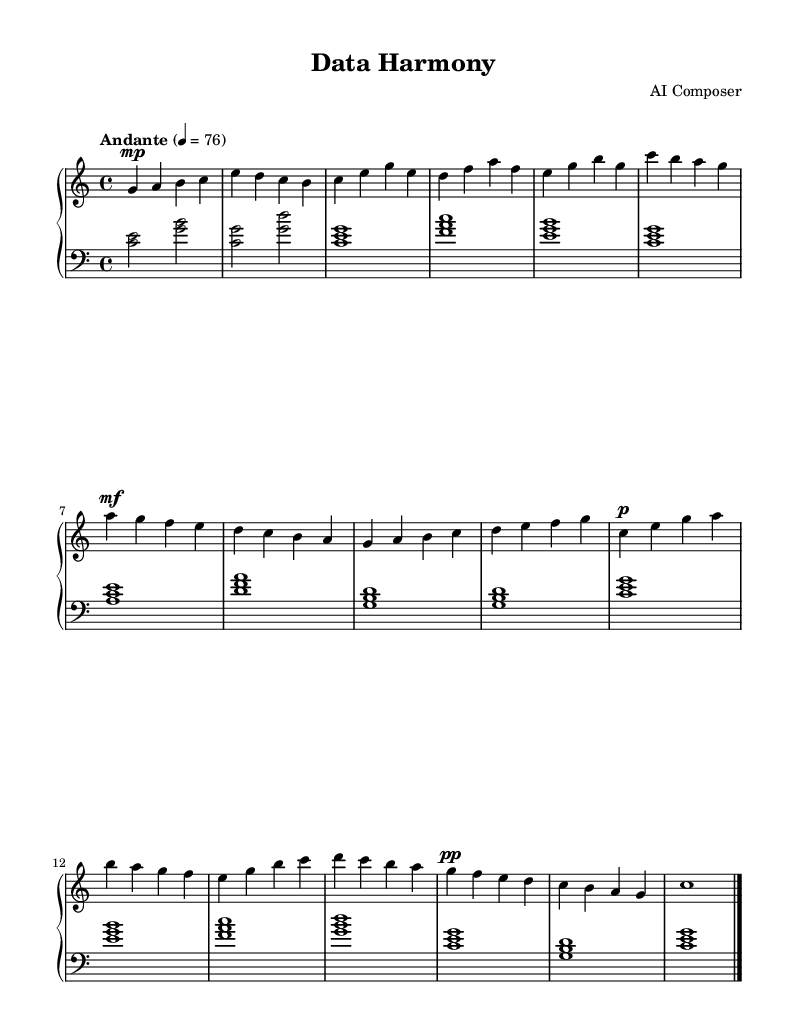What is the key signature of this music? The key signature is C major, which has no sharps or flats indicated on the staff.
Answer: C major What is the time signature of this piece? The time signature is found at the beginning of the score and is noted as 4/4, meaning there are four beats in each measure.
Answer: 4/4 What is the tempo marking of this composition? The tempo marking appears at the beginning of the sheet music and shows "Andante" with a metronome marking of 76, indicating a moderate pace.
Answer: Andante 4 = 76 How many themes are present in this piece? By analyzing the music, we can identify two distinct themes labeled as Theme A and Theme B, and each is repeated in variations throughout the piece.
Answer: 2 Which dynamic is indicated at the beginning of Theme B? The starting dynamic for Theme B is marked as mezzo-forte (mf), suggesting a moderately loud volume for that section of the music.
Answer: mf What is the final measure of the piece? The last measure contains a whole note for C and is followed by a double barline indicating the end of the music combined with a whole note indicating its importance.
Answer: c1  